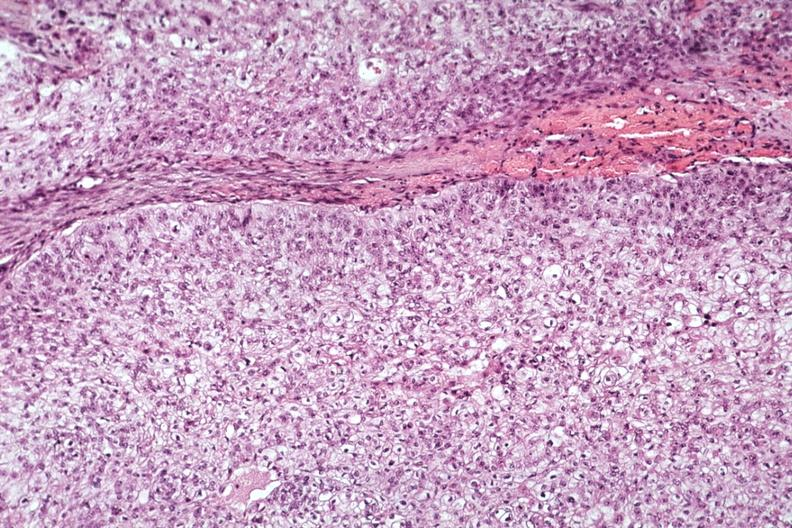s immunostain for growth hormone present?
Answer the question using a single word or phrase. No 